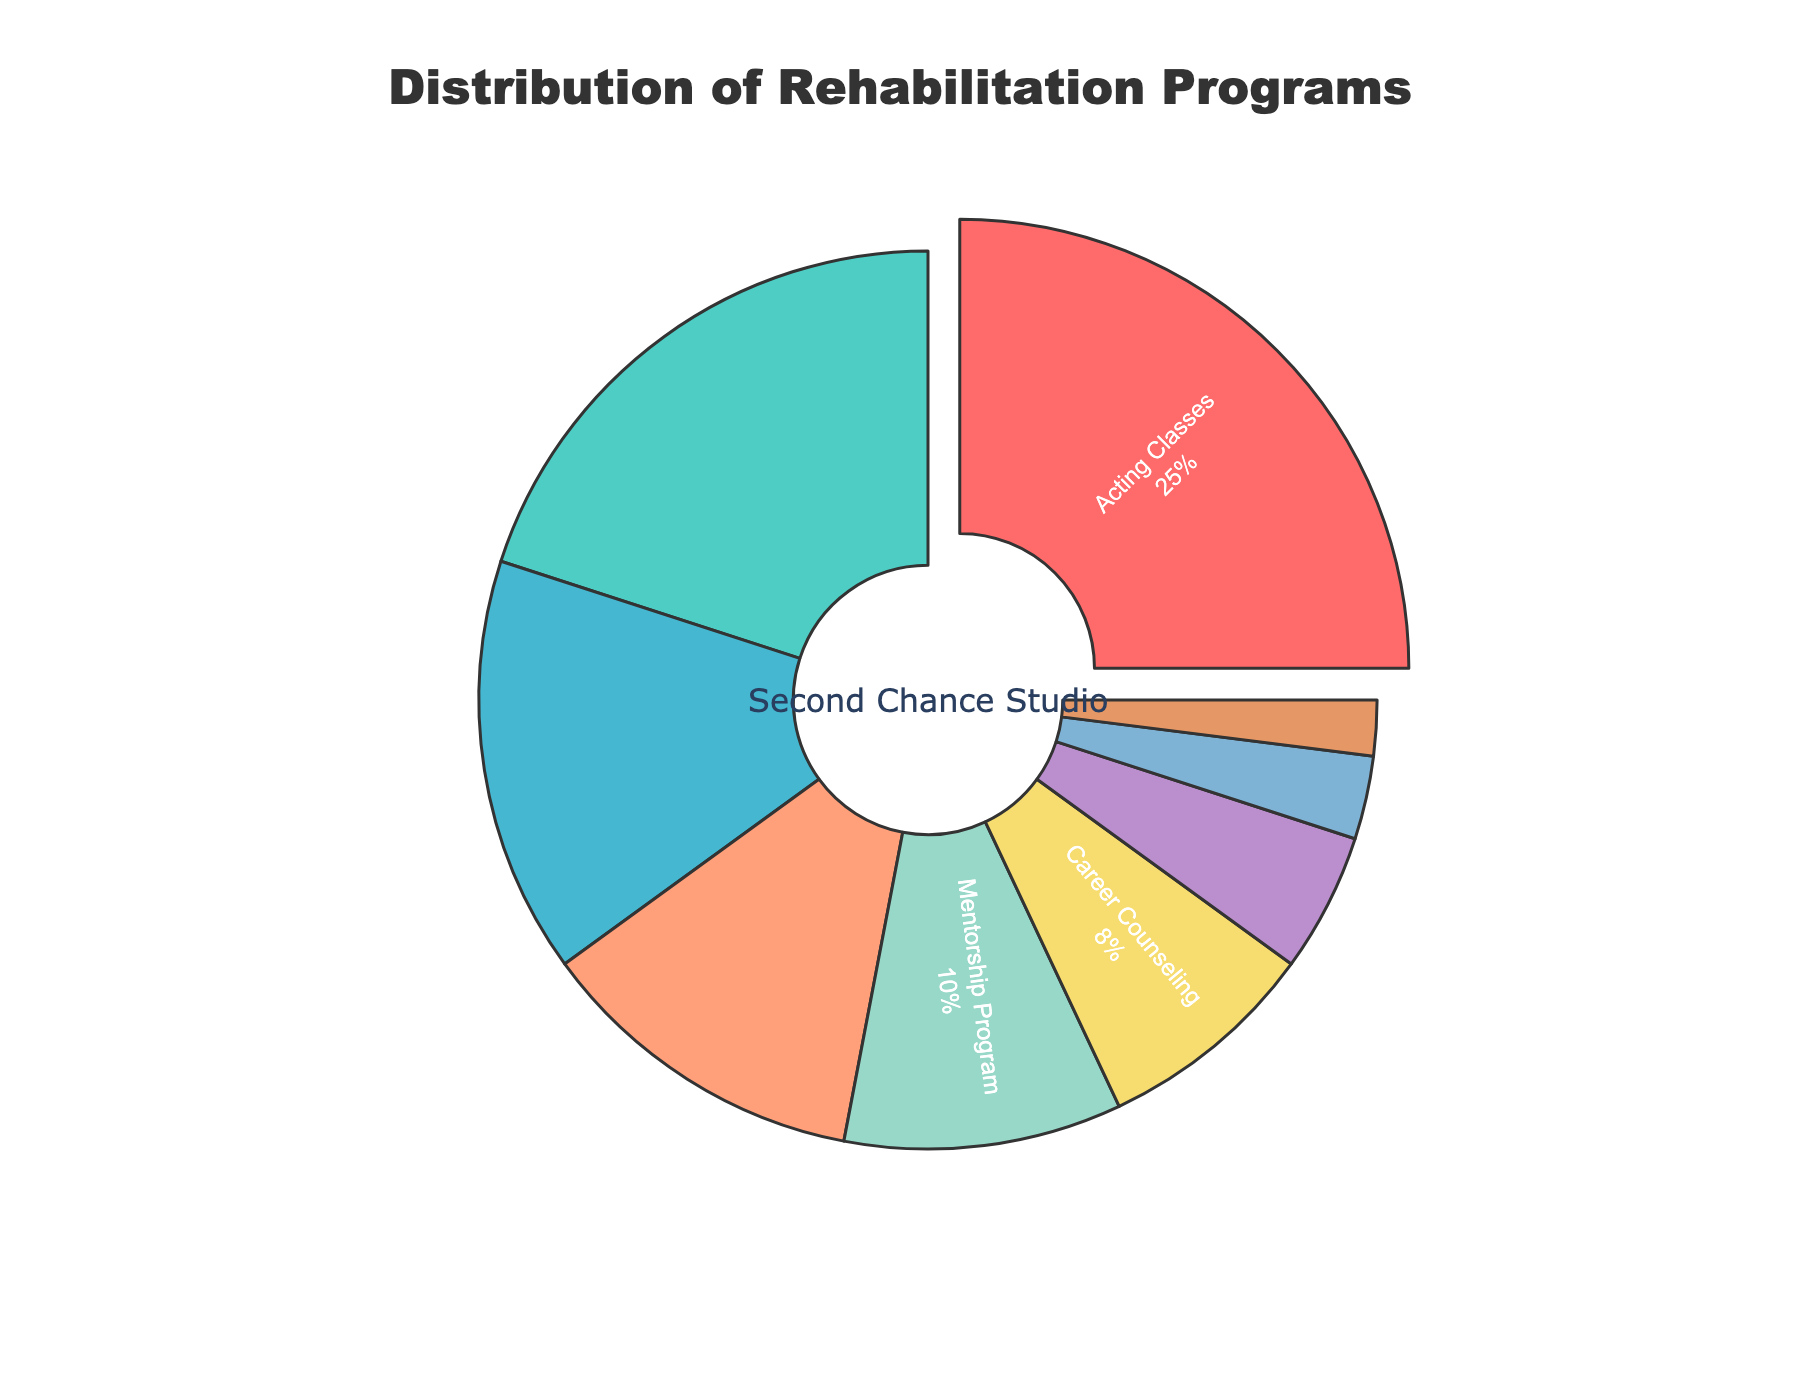What proportion of rehabilitation programs are related to counseling (Substance Abuse Counseling, Career Counseling)? Add the percentages of Substance Abuse Counseling (20%) and Career Counseling (8%) together. 20% + 8% = 28%.
Answer: 28% Which program has the highest percentage? Identify the program with the largest percentage, which is Acting Classes at 25%.
Answer: Acting Classes How much more popular are Acting Classes compared to Conflict Resolution Seminars? Subtract the percentage of Conflict Resolution Seminars (2%) from the percentage of Acting Classes (25%). 25% - 2% = 23%.
Answer: 23% What is the total percentage for the programs that focus on management (Financial Management Workshops, Anger Management Sessions, Stress Management Training)? Add the percentages of Financial Management Workshops (15%), Anger Management Sessions (12%), and Stress Management Training (5%) together. 15% + 12% + 5% = 32%.
Answer: 32% Which two programs have the smallest percentages and what is their combined total? Identify the programs with the smallest percentages: Life Skills Development (3%) and Conflict Resolution Seminars (2%). Add them together. 3% + 2% = 5%.
Answer: Life Skills Development and Conflict Resolution Seminars, 5% What percentage of the programs are mentorship or life skills-related (Mentorship Program, Life Skills Development)? Add the percentages of the Mentorship Program (10%) and Life Skills Development (3%) together. 10% + 3% = 13%.
Answer: 13% How does the percentage of Financial Management Workshops compare to the percentage of Anger Management Sessions? Financial Management Workshops (15%) is 3% higher than Anger Management Sessions (12%).
Answer: Financial Management Workshops is higher by 3% What is the average percentage of all the programs offered at the studio? Calculate the total percentage by summing all the program percentages: 25% + 20% + 15% + 12% + 10% + 8% + 5% + 3% + 2% = 100%. There are 9 programs, so the average is 100% / 9. 100% / 9 ≈ 11.11%.
Answer: 11.11% Which program is closest in percentage to the average percentage of 11.11%? The percentages close to the average (11.11%) are 12% (Anger Management Sessions) and 10% (Mentorship Program). Identify the closer one through comparison.
Answer: Anger Management Sessions 